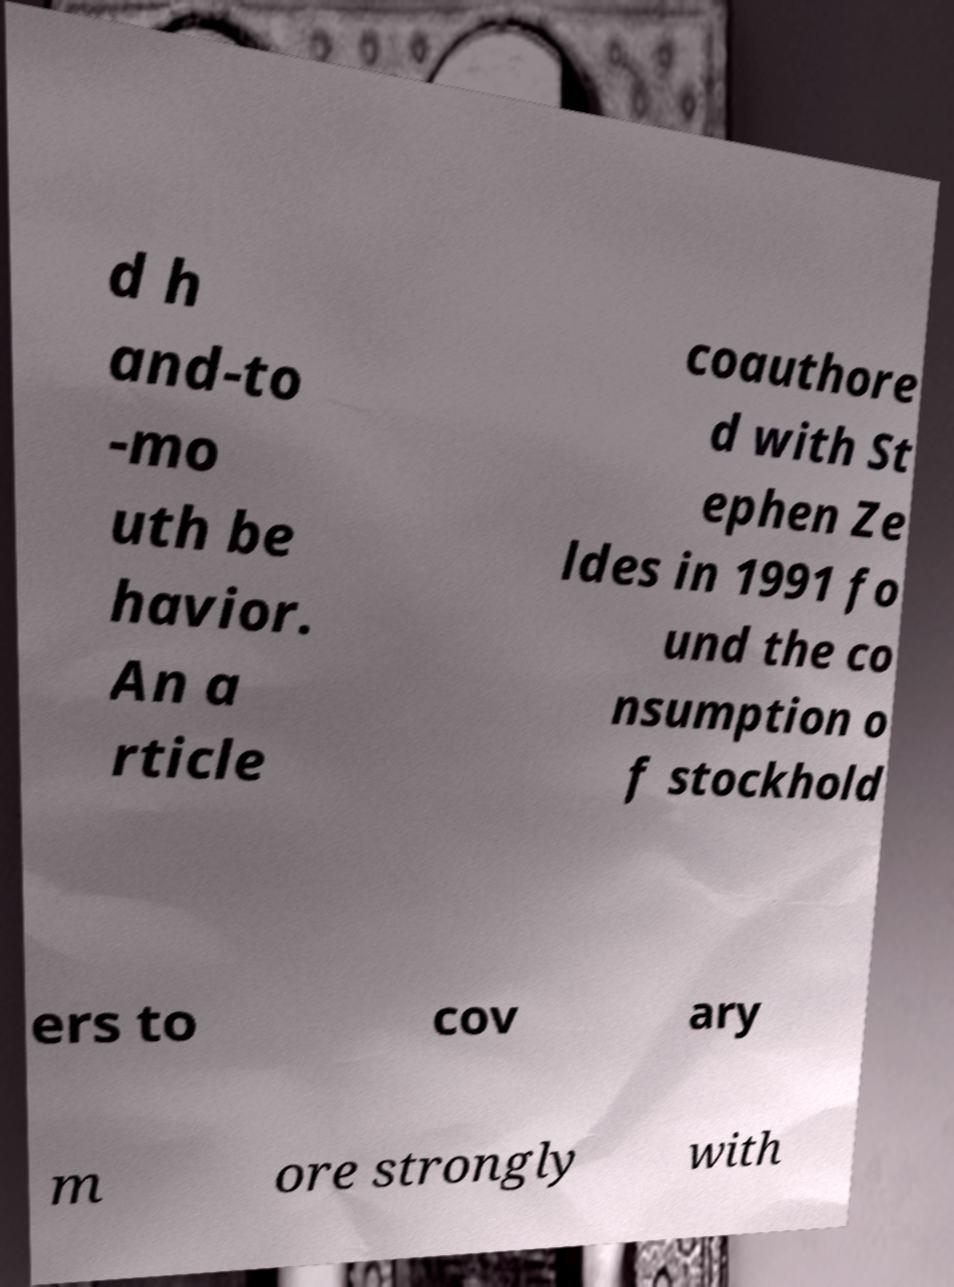Please read and relay the text visible in this image. What does it say? d h and-to -mo uth be havior. An a rticle coauthore d with St ephen Ze ldes in 1991 fo und the co nsumption o f stockhold ers to cov ary m ore strongly with 